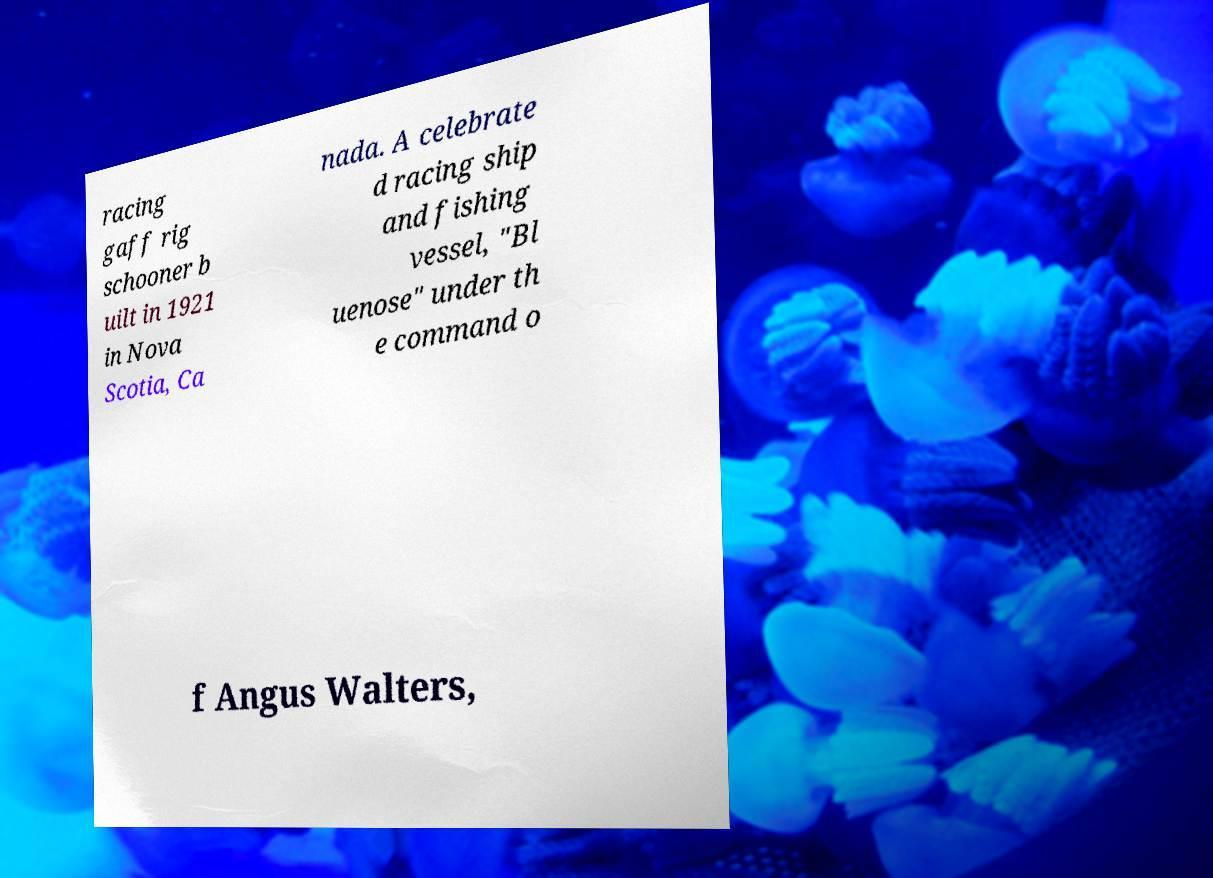What messages or text are displayed in this image? I need them in a readable, typed format. racing gaff rig schooner b uilt in 1921 in Nova Scotia, Ca nada. A celebrate d racing ship and fishing vessel, "Bl uenose" under th e command o f Angus Walters, 